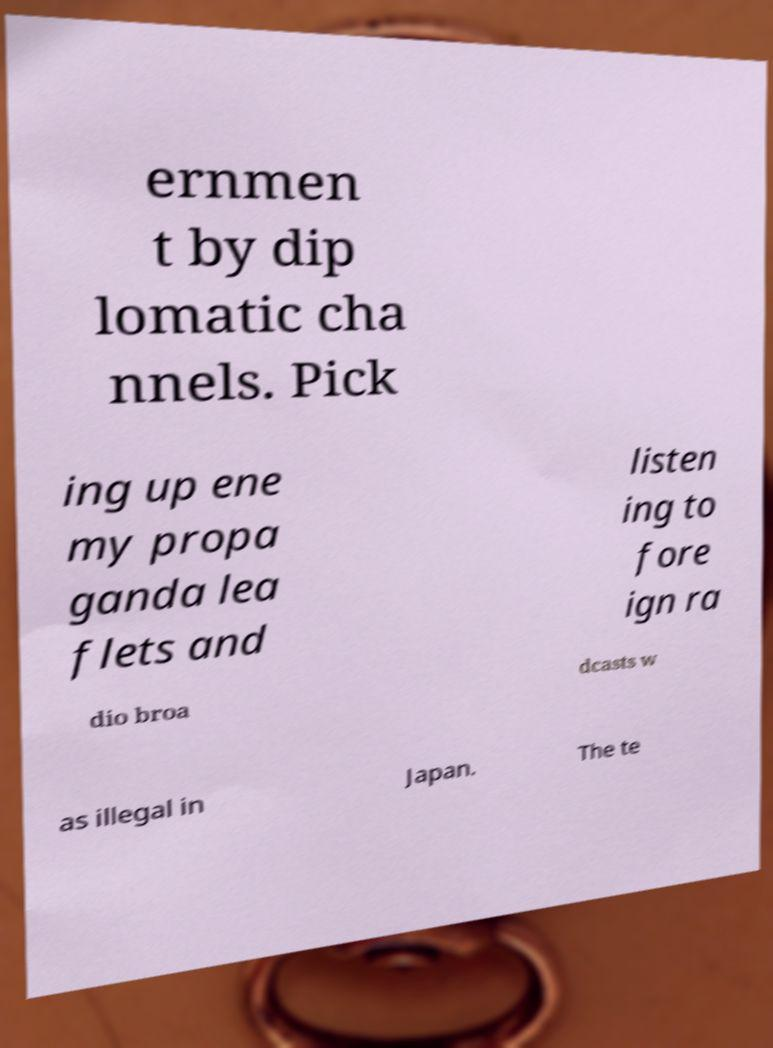For documentation purposes, I need the text within this image transcribed. Could you provide that? ernmen t by dip lomatic cha nnels. Pick ing up ene my propa ganda lea flets and listen ing to fore ign ra dio broa dcasts w as illegal in Japan. The te 